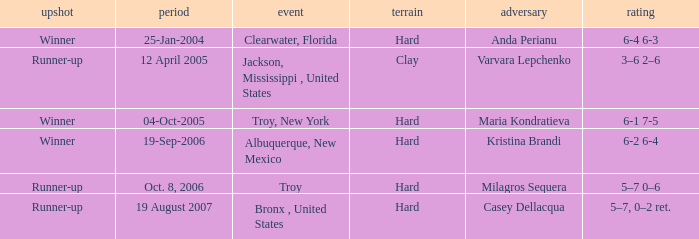What is the score of the game that was played against Maria Kondratieva? 6-1 7-5. 